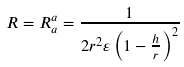Convert formula to latex. <formula><loc_0><loc_0><loc_500><loc_500>R = R _ { a } ^ { a } = \frac { 1 } { 2 r ^ { 2 } \varepsilon \left ( 1 - \frac { h } { r } \right ) ^ { 2 } }</formula> 